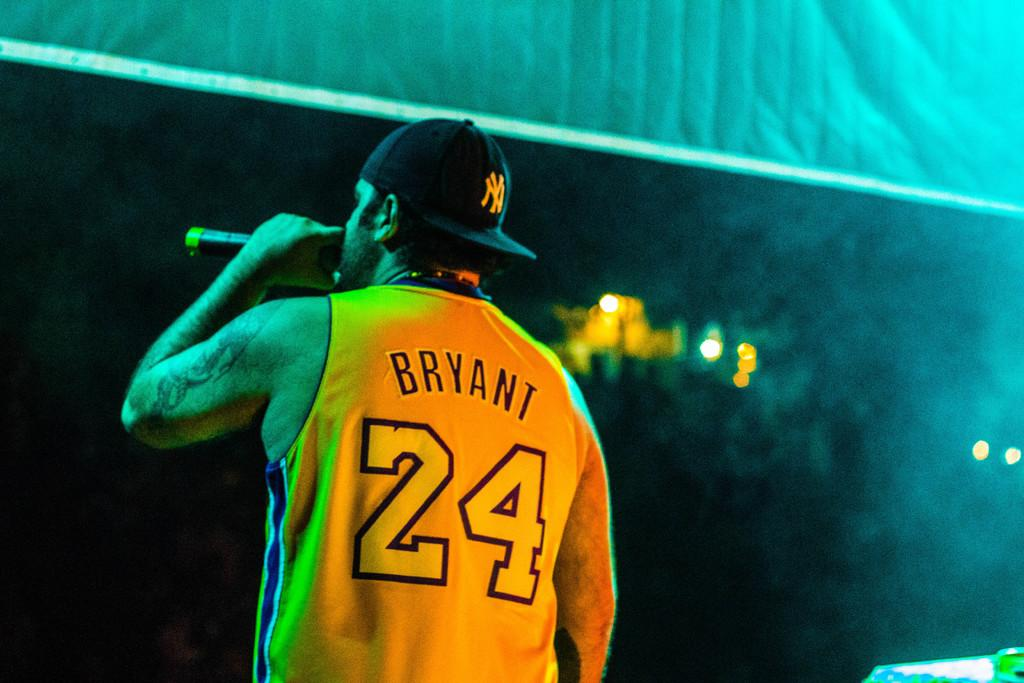Provide a one-sentence caption for the provided image. A man wearing a yellow Jersey that says Bryant 24 holds a microphone. 